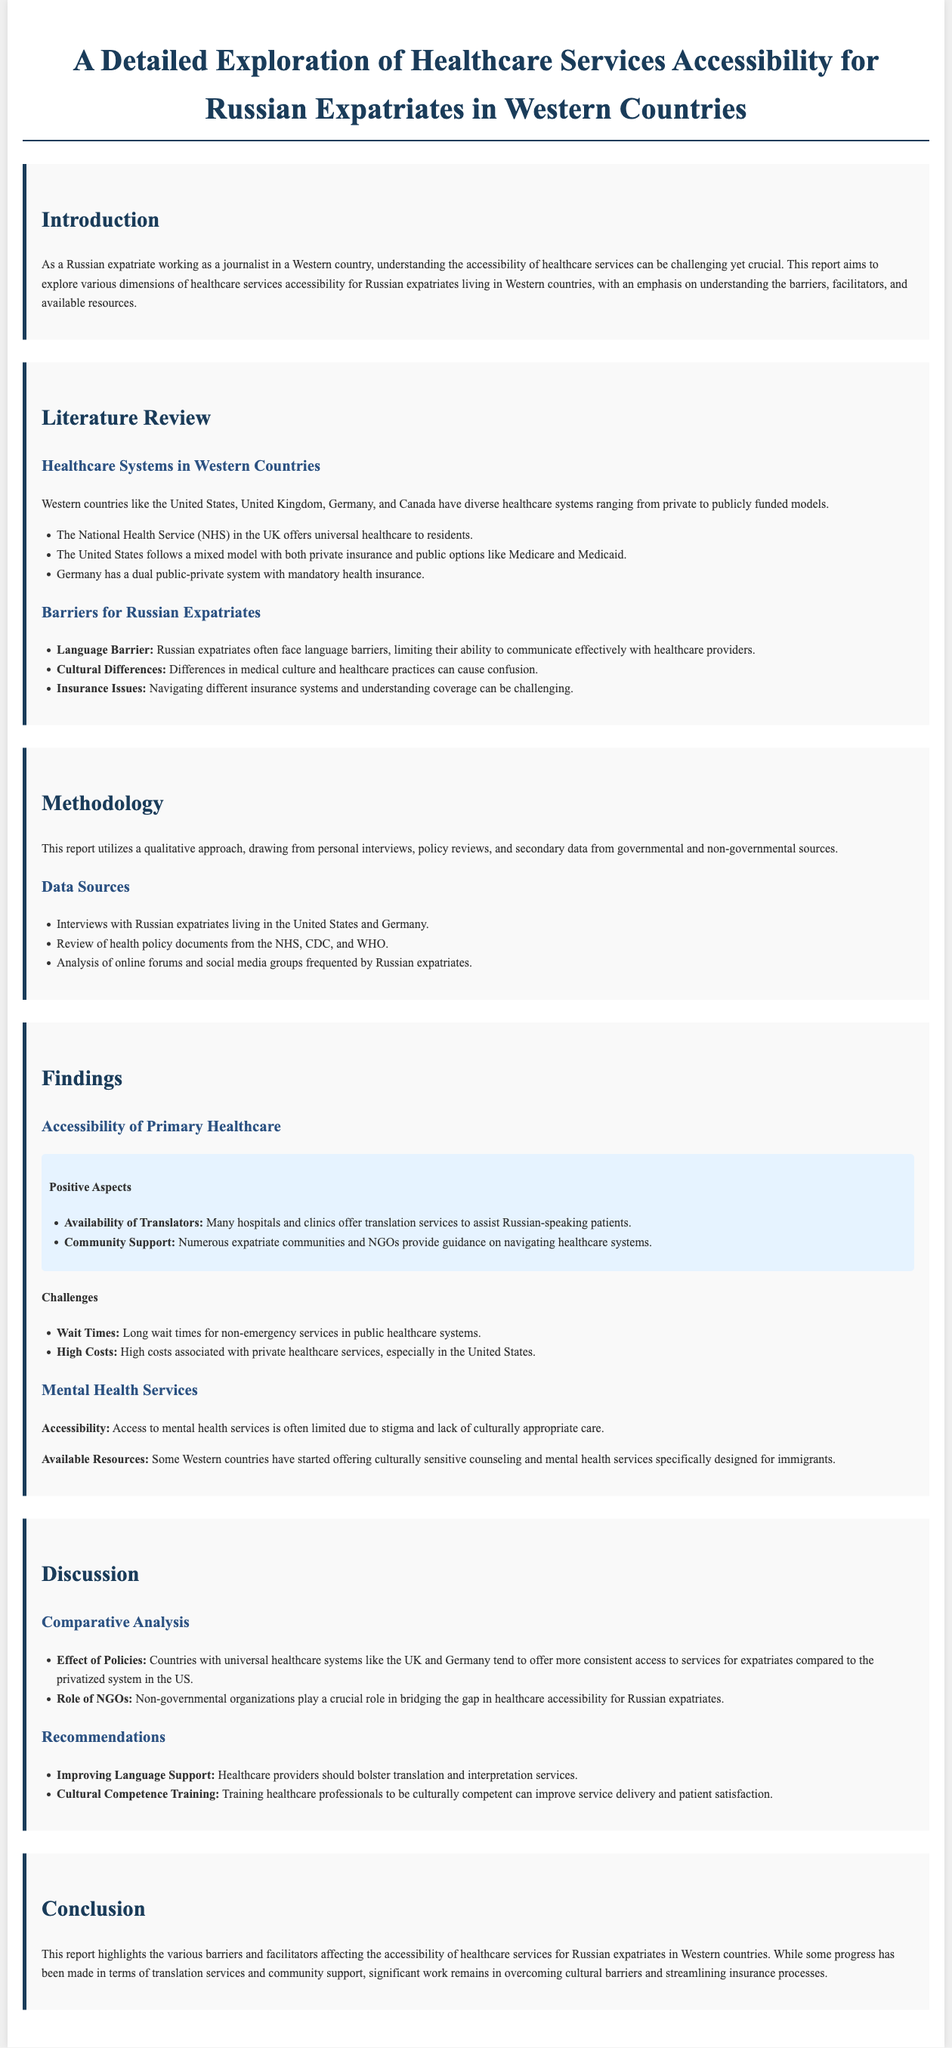What is the primary focus of the report? The report explores healthcare services accessibility for Russian expatriates in Western countries.
Answer: healthcare services accessibility for Russian expatriates What healthcare system does the UK use? The UK employs the National Health Service (NHS) model for universal healthcare.
Answer: National Health Service (NHS) What is a major barrier for Russian expatriates in accessing healthcare? Language barriers limit effective communication with healthcare providers.
Answer: Language Barrier Which two countries had interviews conducted for this report? Interviews were conducted with Russian expatriates living in the United States and Germany.
Answer: United States and Germany What recommendation is made to improve healthcare services? Strengthening language support through translation and interpretation services is recommended.
Answer: Improving Language Support How do public healthcare systems compare to privatized ones according to the report? Countries with universal healthcare systems like the UK and Germany offer more consistent access to services.
Answer: More consistent access What type of approach does the report use for data collection? The report utilizes a qualitative approach for data collection.
Answer: qualitative approach What role do non-governmental organizations play according to the findings? NGOs play a crucial role in bridging the gap in healthcare accessibility.
Answer: bridging the gap 